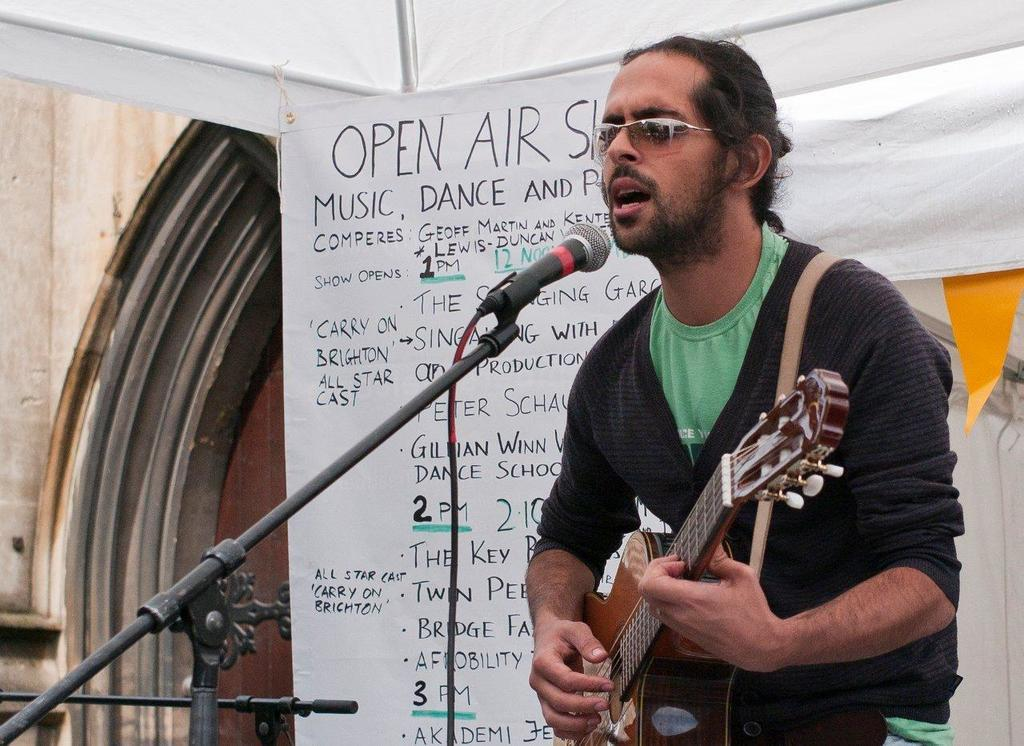What is the person in the image doing? The person is standing and playing guitar in the image. What else is the person doing while playing the guitar? The person is singing. What structure can be seen in the background of the image? There is a tent in the image. What is the person using to amplify their voice? There is a microphone at the front of the person. What is the person using to support their guitar? There is a board at the back of the person. Can you hear the person laughing in the image? There is no indication of laughter in the image. 